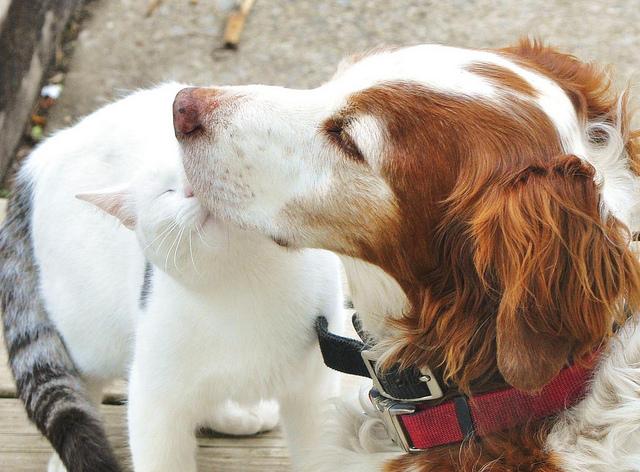Are these two animals friends?
Be succinct. Yes. Is the dog's tongue out?
Concise answer only. No. What color is the collar?
Be succinct. Red. What color is the cat?
Short answer required. White. 